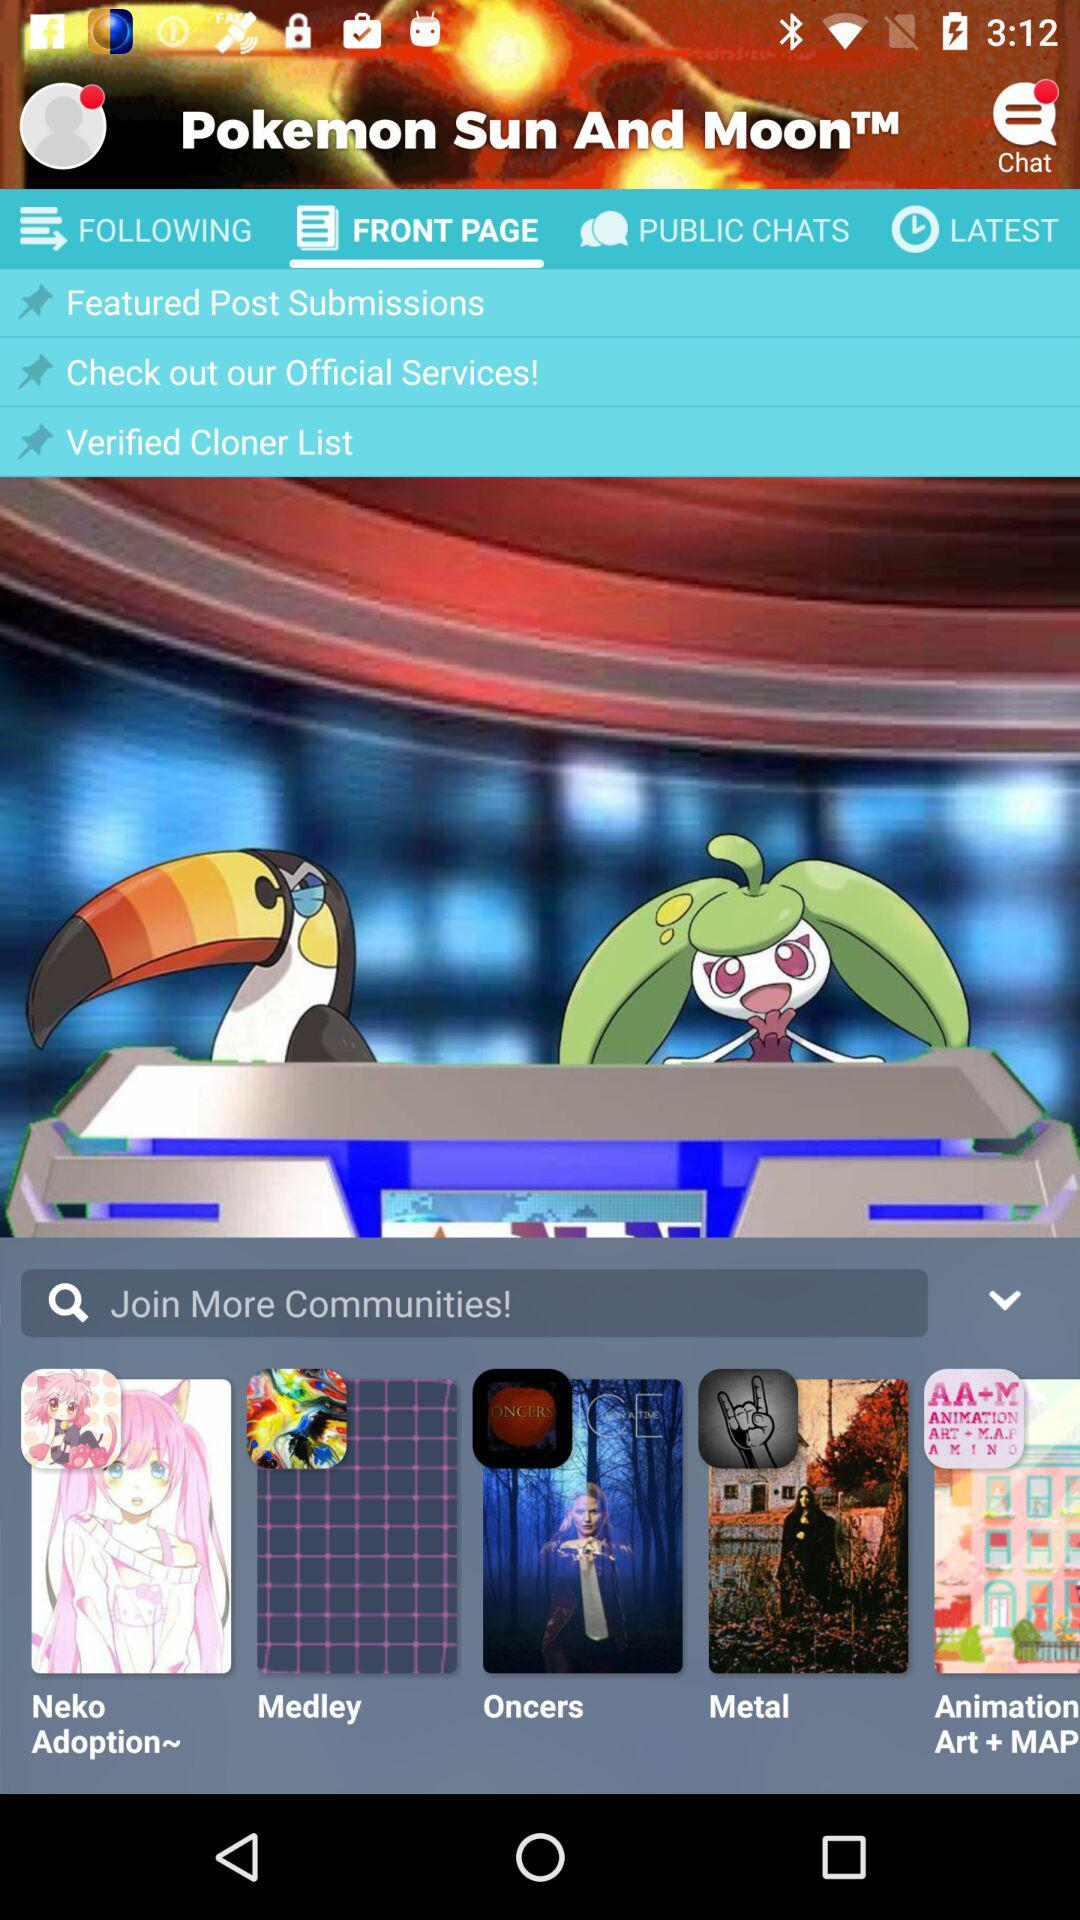Which tab am I on? The tab is "FRONT PAGE". 